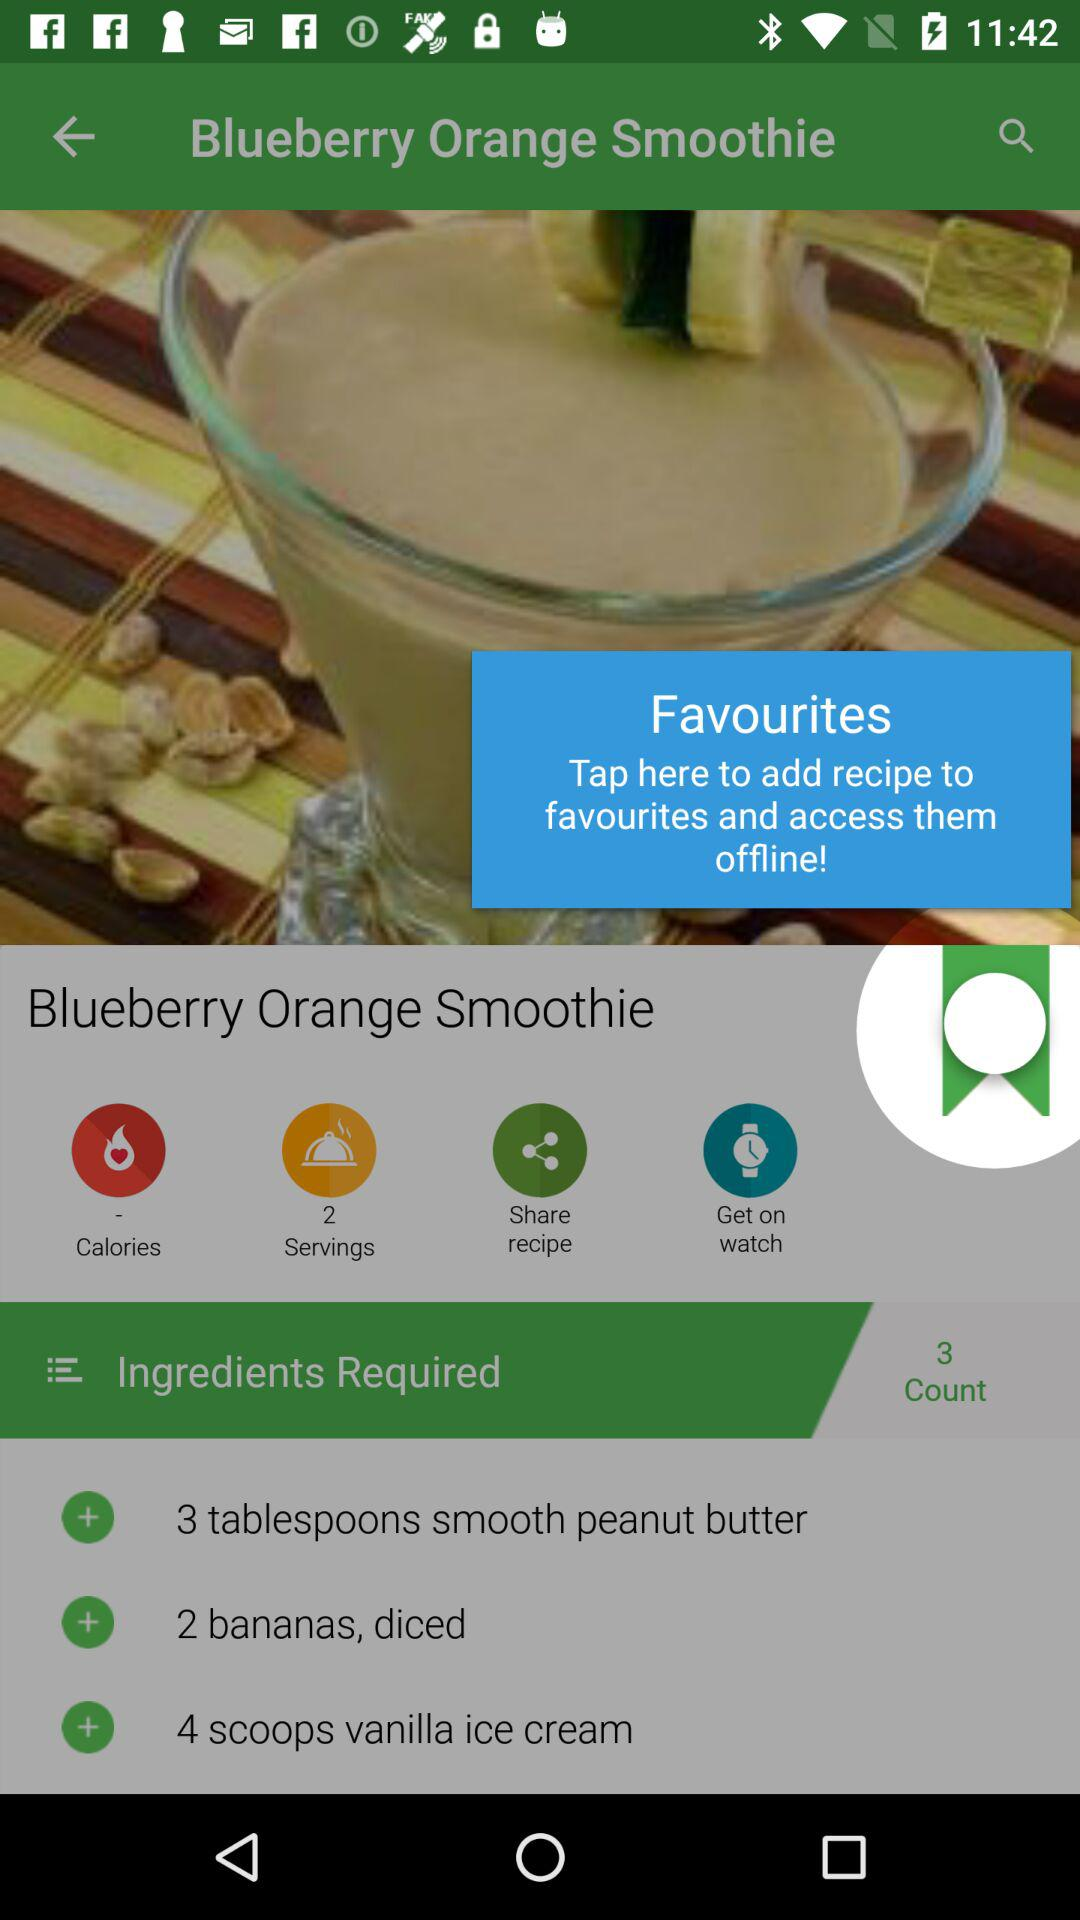How many ingredients are in this recipe?
Answer the question using a single word or phrase. 3 